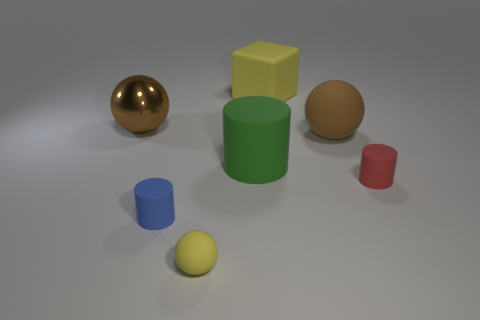Subtract all blue cylinders. How many cylinders are left? 2 Subtract all red cylinders. How many cylinders are left? 2 Add 3 tiny purple spheres. How many objects exist? 10 Subtract 3 spheres. How many spheres are left? 0 Subtract 0 brown blocks. How many objects are left? 7 Subtract all balls. How many objects are left? 4 Subtract all gray cylinders. Subtract all blue blocks. How many cylinders are left? 3 Subtract all blue blocks. How many green cylinders are left? 1 Subtract all blue spheres. Subtract all yellow things. How many objects are left? 5 Add 6 blue matte objects. How many blue matte objects are left? 7 